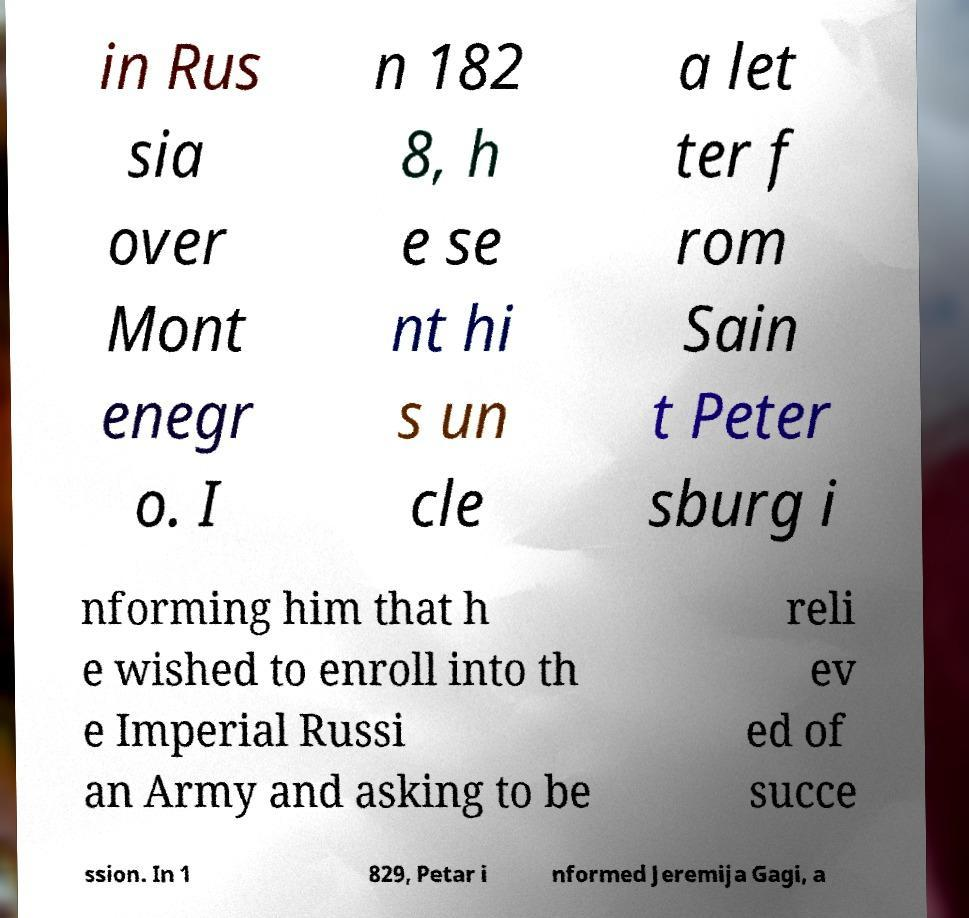Please identify and transcribe the text found in this image. in Rus sia over Mont enegr o. I n 182 8, h e se nt hi s un cle a let ter f rom Sain t Peter sburg i nforming him that h e wished to enroll into th e Imperial Russi an Army and asking to be reli ev ed of succe ssion. In 1 829, Petar i nformed Jeremija Gagi, a 